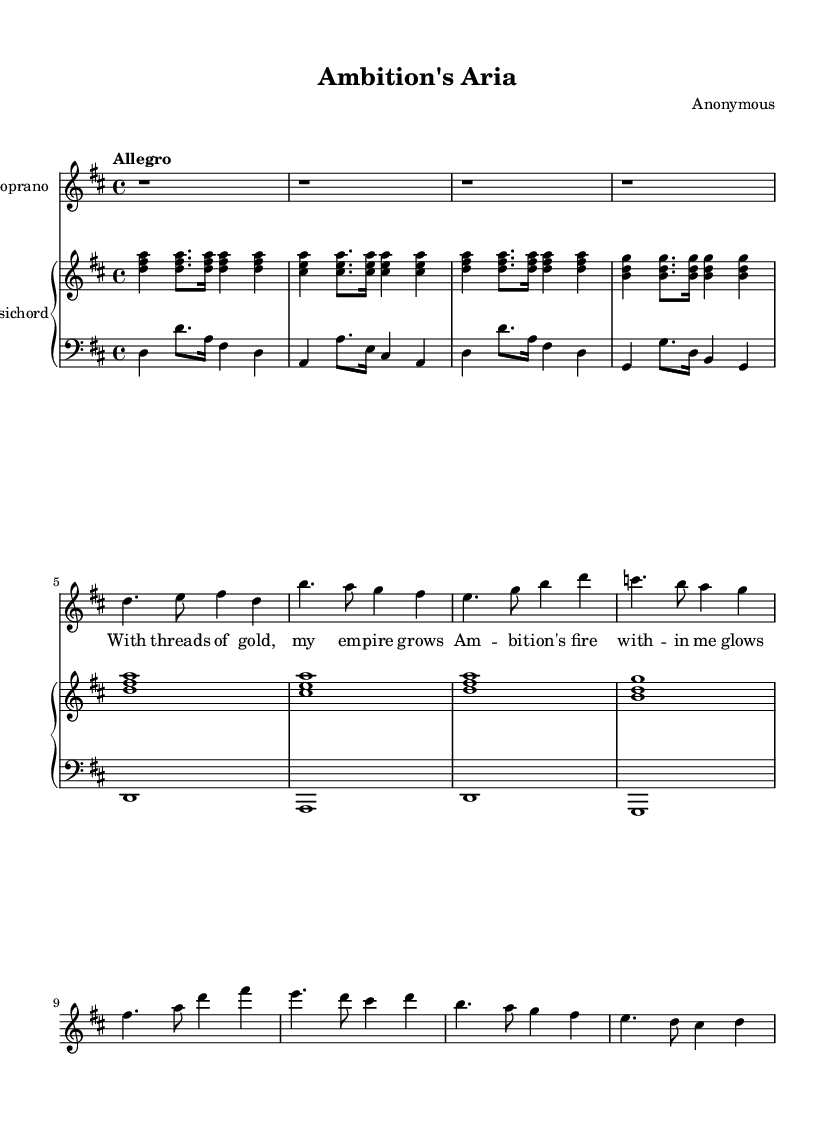What is the time signature of this music? The time signature is indicated in the beginning of the sheet music as 4/4, which means there are four beats in each measure and the quarter note receives one beat.
Answer: 4/4 What is the key signature of this music? The key signature is D major, which is indicated by the presence of two sharps (F# and C#) at the beginning of the staff.
Answer: D major What is the tempo marking for this piece? The tempo marking is indicated above the staff and reads "Allegro," which suggests a fast and lively pace for the performance.
Answer: Allegro How many measures are in the introduction section? The introduction section consists of four measures, as indicated by the four sets of notation at the beginning of the score.
Answer: 4 What is the starting pitch of the soprano part? The starting pitch of the soprano part is D in the middle octave, as the notation begins there in the first measure.
Answer: D What is the highest note in the soprano part? The highest note in the soprano part is B, which appears in the second measure as shown in the notation.
Answer: B How many different sections can be identified in this aria? The aria can be divided into at least two distinct sections: the introduction and Verse 1, identified by their different melodic lines and lyrics.
Answer: 2 